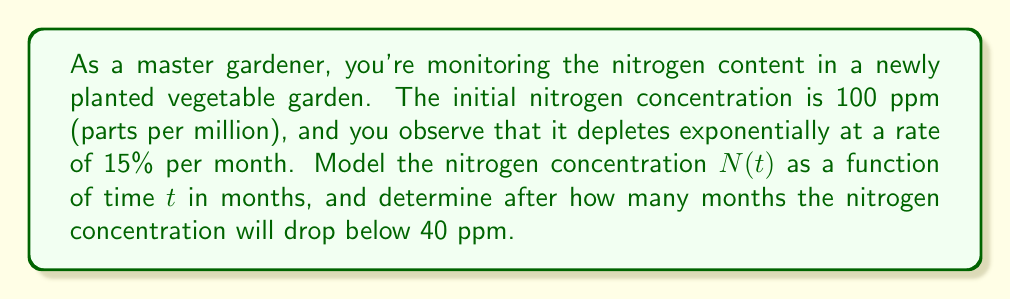Could you help me with this problem? 1) First, we need to model the nitrogen concentration using an exponential function. The general form is:

   $N(t) = N_0 \cdot e^{-kt}$

   Where $N_0$ is the initial concentration, $k$ is the decay rate, and $t$ is time in months.

2) We know $N_0 = 100$ ppm and the decay rate is 15% = 0.15 per month.

3) Our model becomes:

   $N(t) = 100 \cdot e^{-0.15t}$

4) To find when the concentration drops below 40 ppm, we solve:

   $40 = 100 \cdot e^{-0.15t}$

5) Divide both sides by 100:

   $0.4 = e^{-0.15t}$

6) Take the natural log of both sides:

   $\ln(0.4) = -0.15t$

7) Solve for $t$:

   $t = \frac{\ln(0.4)}{-0.15} \approx 6.15$ months

8) Since we can't have a fractional month in this context, we round up to the next whole month.
Answer: 7 months 